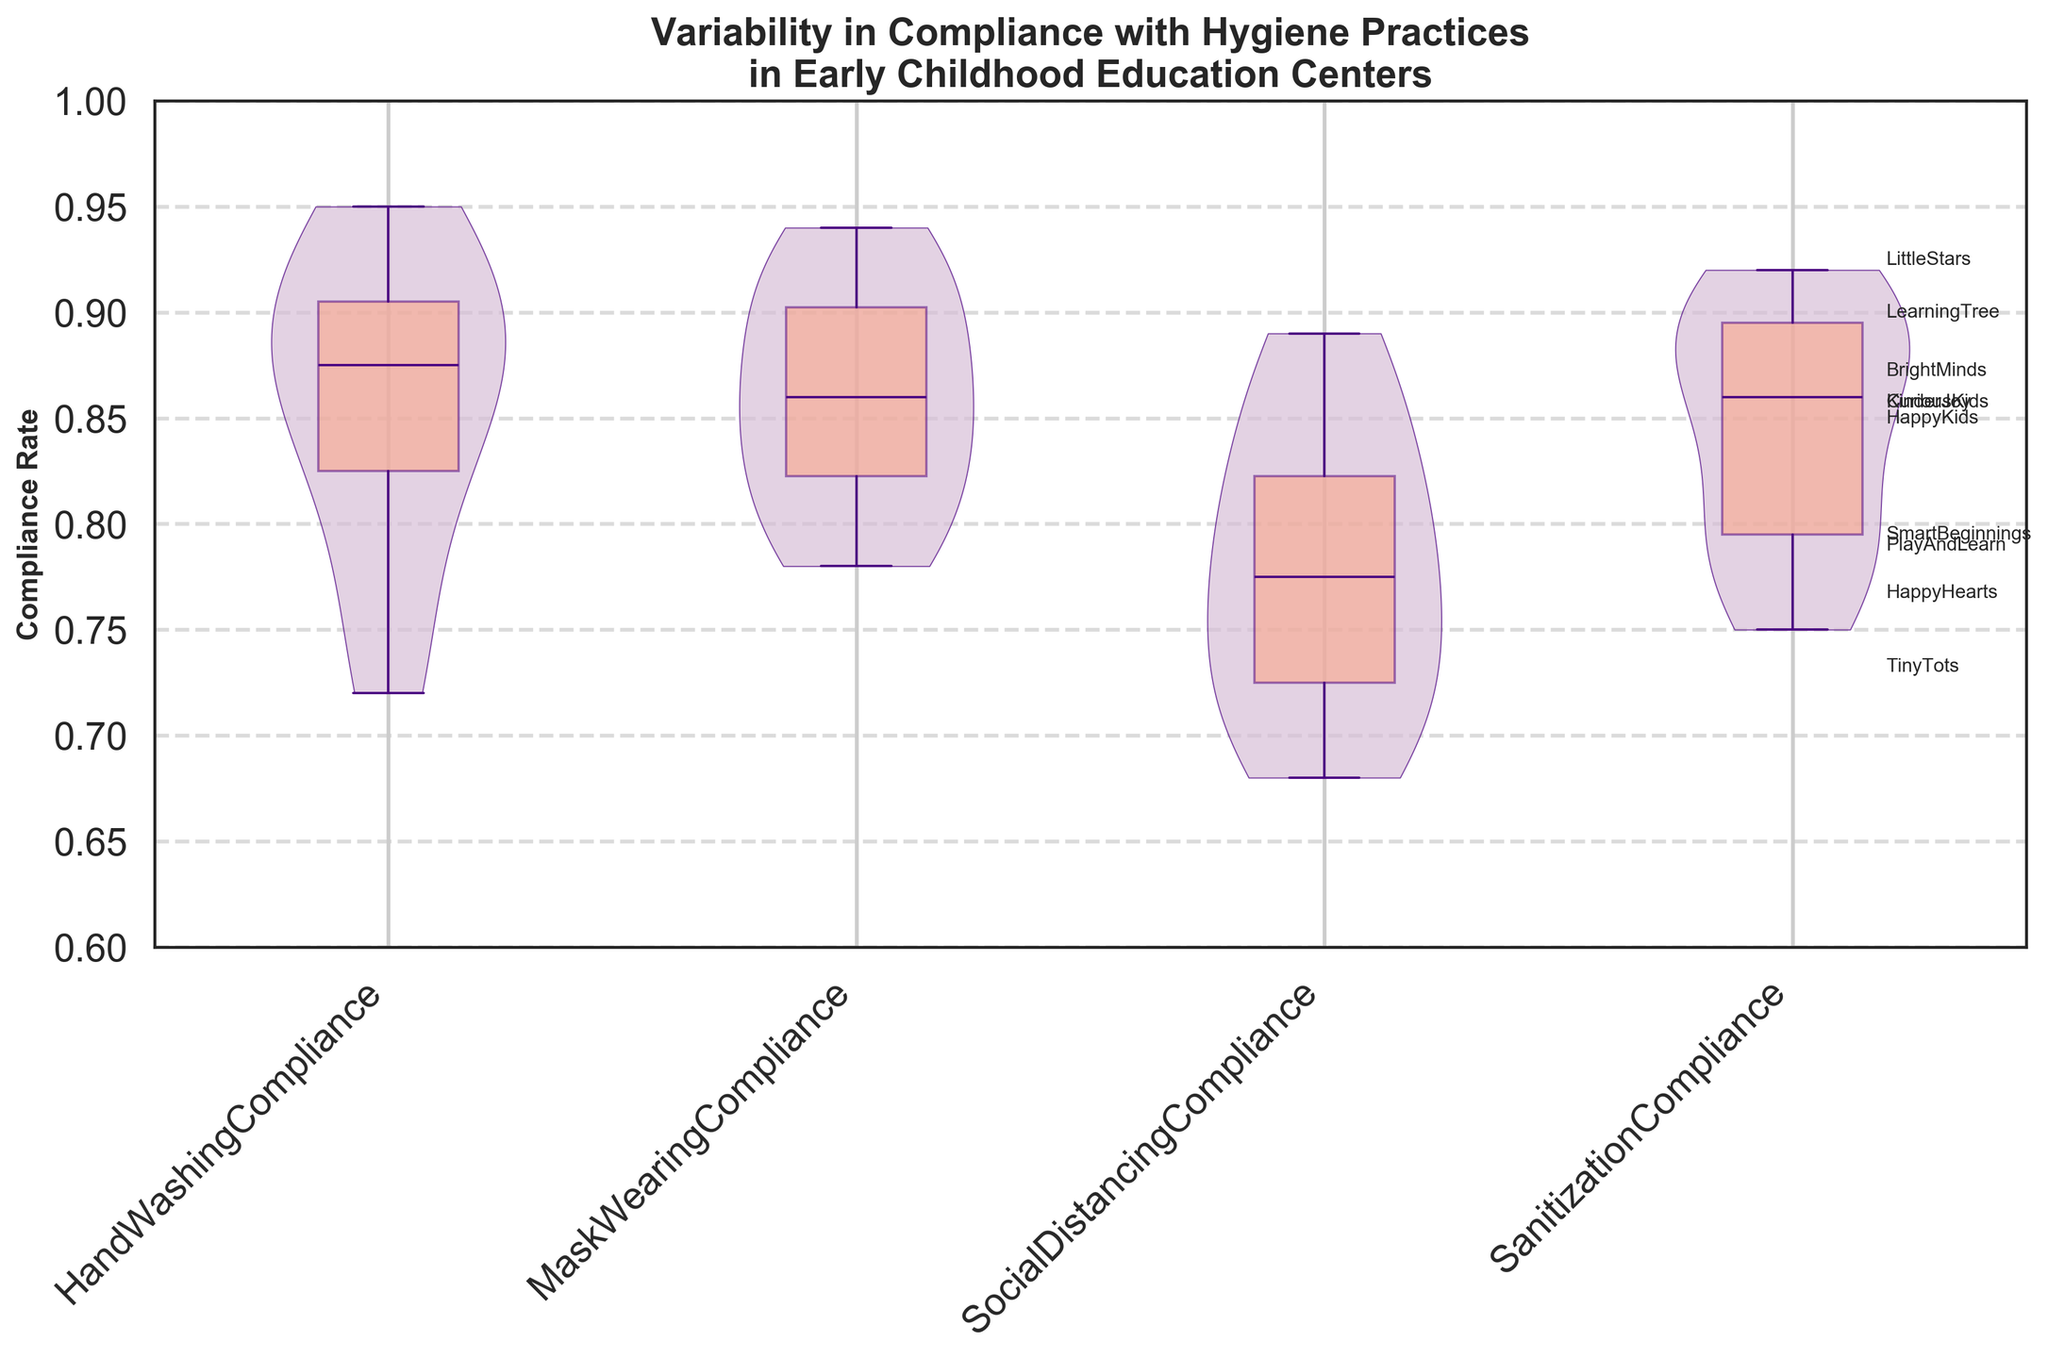What is the title of the figure? The title of the figure is usually located at the top in bold fonts to give an overview of the visualized data. By looking at the top center of the plot, it's clear that the title is mentioned there.
Answer: Variability in Compliance with Hygiene Practices in Early Childhood Education Centers What does the y-axis represent in this figure? The y-axis label is usually positioned vertically along the left side of the plot. In this figure, it represents the rate of compliance with hygiene practices.
Answer: Compliance Rate Which hygiene practice shows the highest compliance across all centers on average? To determine this, look at the violins and box plots corresponding to each hygiene practice. The practice with the highest average compliance rate is where violins and medians (lines inside box plots) are higher. Social Distancing Compliance, Mask Wearing Compliance, Sanitization Compliance, and Hand Washing Compliance are compared. Mask Wearing Compliance and Sanitization Compliance both have high average compliance, but Sanitization Compliance is slightly higher.
Answer: Sanitization Compliance Which early childhood education center has the highest compliance rate for Hand Washing? The text annotations on the right side provide information about each center's average rate of compliance across all practices. For Hand Washing Compliance specifically, you can refer to the top data point in the first violin plot.
Answer: LittleStars How does Hand Washing Compliance compare between HappyKids and PlayAndLearn? In the first violin plot, locate the positions of HappyKids and PlayAndLearn. HappyKids has a higher Hand Washing Compliance rate compared to PlayAndLearn, as indicated by their respective positions in the plot.
Answer: HappyKids has higher compliance than PlayAndLearn Which center has the lowest compliance rate for Social Distancing? By examining the third violin plot, the center with the lowest position on the y-axis within that plot represents the center with the lowest compliance rate for Social Distancing.
Answer: TinyTots What is the range of Mask Wearing Compliance rates shown in the figure? The range can be identified by looking at the extents of the violin plot for Mask Wearing Compliance, which is the second plot. It typically varies between the minimum and maximum compliance rates observed. The plot ranges from approximately 0.78 to 0.94.
Answer: 0.78 to 0.94 Which hygiene practice has the widest variability in compliance rates? The width and spread of the violin plot indicate the variability of the data. The practice with the widest violin plot has the highest variability. The first violin plot (Hand Washing) appears to be the widest, indicating the most variability.
Answer: Hand Washing Compliance Is compliance with Mask Wearing generally higher or lower than Social Distancing across the centers? By examining the quartile ranges and median lines inside the violin plots for Mask Wearing (second plot) and Social Distancing (third plot), it can be seen that the median for Mask Wearing is higher, indicating generally higher compliance with Mask Wearing.
Answer: Higher How do the compliance rates for Hand Washing and Sanitization compare across different centers? To compare compliance rates across different centers, observe the first violin plot for Hand Washing and the fourth for Sanitization. The medians of the respective box plots and the overall spread indicate that Sanitization Compliance is generally higher and less variable compared to Hand Washing Compliance.
Answer: Sanitization has generally higher and less variable compliance rates than Hand Washing 